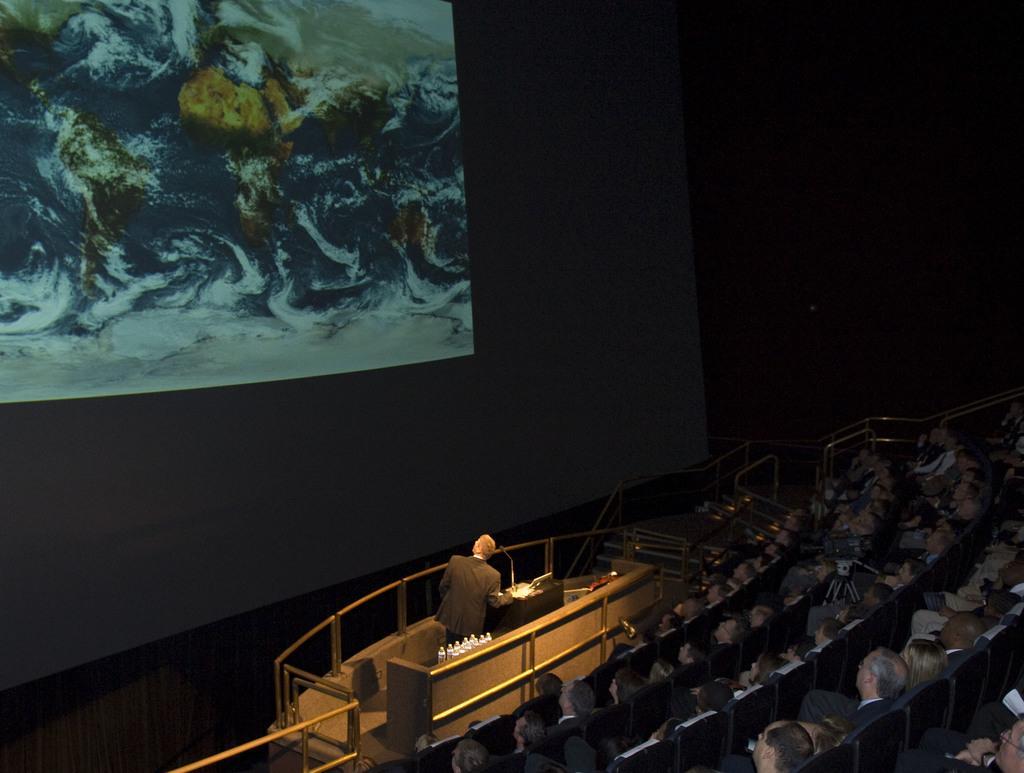Could you give a brief overview of what you see in this image? In the picture we can see a hall with many people sitting on the chairs in a row wise and in front of them, we can see a man standing on the stage and it is covered with railing and behind him we can see a black color wall with a painting on it. 